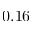<formula> <loc_0><loc_0><loc_500><loc_500>0 . 1 6</formula> 